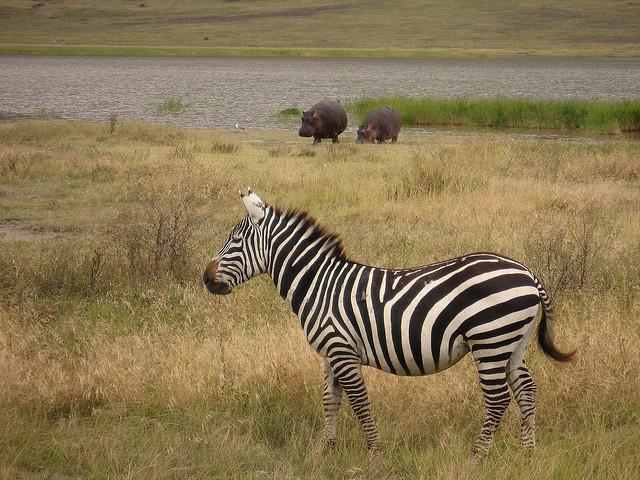How many zebras can you see?
Give a very brief answer. 1. How many women with blue shirts are behind the vegetables?
Give a very brief answer. 0. 